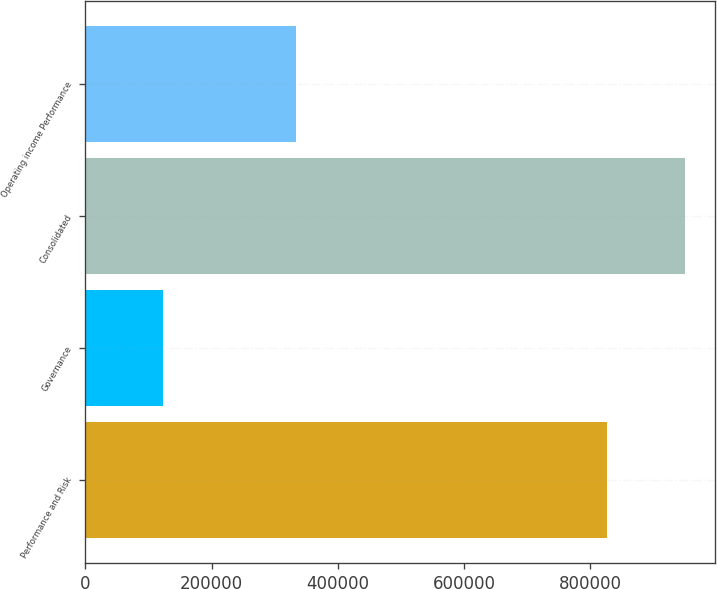<chart> <loc_0><loc_0><loc_500><loc_500><bar_chart><fcel>Performance and Risk<fcel>Governance<fcel>Consolidated<fcel>Operating income Performance<nl><fcel>826990<fcel>123151<fcel>950141<fcel>334547<nl></chart> 